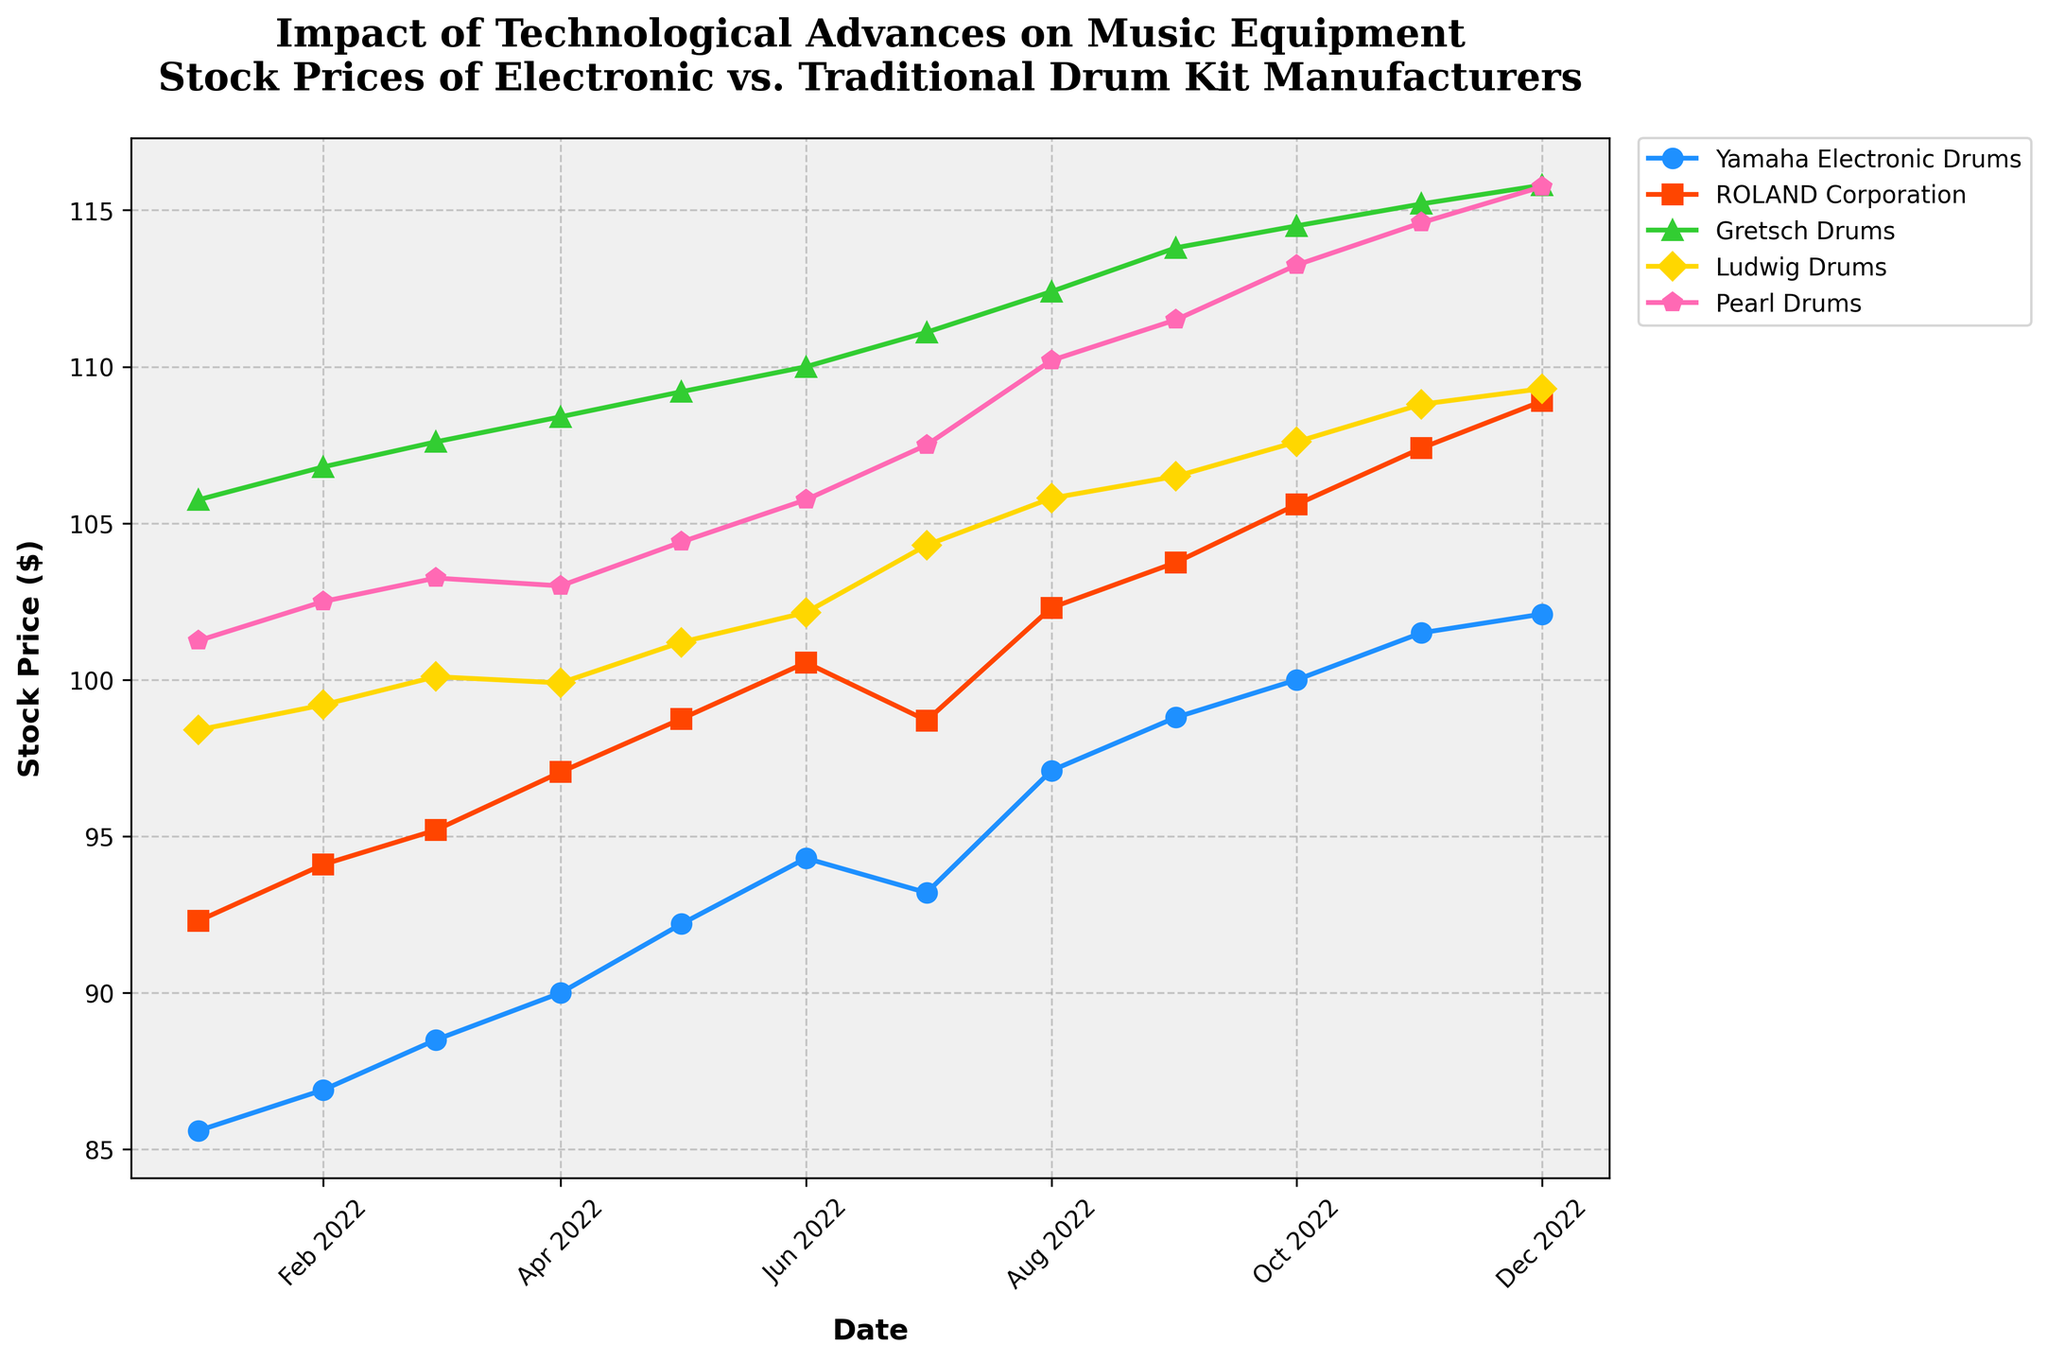What is the title of the figure? The title is prominently displayed at the top of the figure and reads "Impact of Technological Advances on Music Equipment\nStock Prices of Electronic vs. Traditional Drum Kit Manufacturers."
Answer: Impact of Technological Advances on Music Equipment\nStock Prices of Electronic vs. Traditional Drum Kit Manufacturers What dates are shown on the x-axis? The x-axis of the figure represents time, starting from January 2022 and ending in December 2022. The months are spaced at two-month intervals.
Answer: January 2022 to December 2022 Which manufacturer had the highest stock price in December 2022? By looking at the data points for December 2022, it is evident that Gretsch Drums had the highest stock price among the manufacturers listed.
Answer: Gretsch Drums How did the stock price of Yamaha Electronic Drums change from January to December 2022? To assess this, look at the starting point for Yamaha Electronic Drums in January 2022 and compare it to its point in December 2022. The stock price increased from 85.60 to 102.10.
Answer: Increased by 16.5 Which two manufacturers showed significant growth in their stock prices during the year? To determine this, observe which lines have a noticeable upward trend. Both Yamaha Electronic Drums and ROLAND Corporation show significant growth in their stock prices throughout the year.
Answer: Yamaha Electronic Drums, ROLAND Corporation Which manufacturer had the smallest fluctuation in stock price throughout the year? By examining the spread of the data points for each manufacturer, Ludwig Drums had the smallest range of fluctuation. Its prices are relatively stable, ranging from 98.40 to 109.30.
Answer: Ludwig Drums What was the average stock price of Pearl Drums in the second half of 2022? To find this, sum the stock prices of Pearl Drums from July to December (107.50 + 110.20 + 111.50 + 113.25 + 114.60 + 115.75) and divide by the number of months (6).  It calculates to (672.80 / 6 = 112.13).
Answer: 112.13 Which manufacturer had a drop in its stock price between any two consecutive months? By viewing the lines for any downward trends between consecutive months, Yamaha Electronic Drums had a drop from June 2022 (94.30) to July 2022 (93.20).
Answer: Yamaha Electronic Drums Whose stock prices were always lower than Gretsch Drums throughout 2022? By comparing all other lines to Gretsch Drums, the stock prices of Yamaha Electronic Drums and ROLAND Corporation were always lower.
Answer: Yamaha Electronic Drums, ROLAND Corporation 